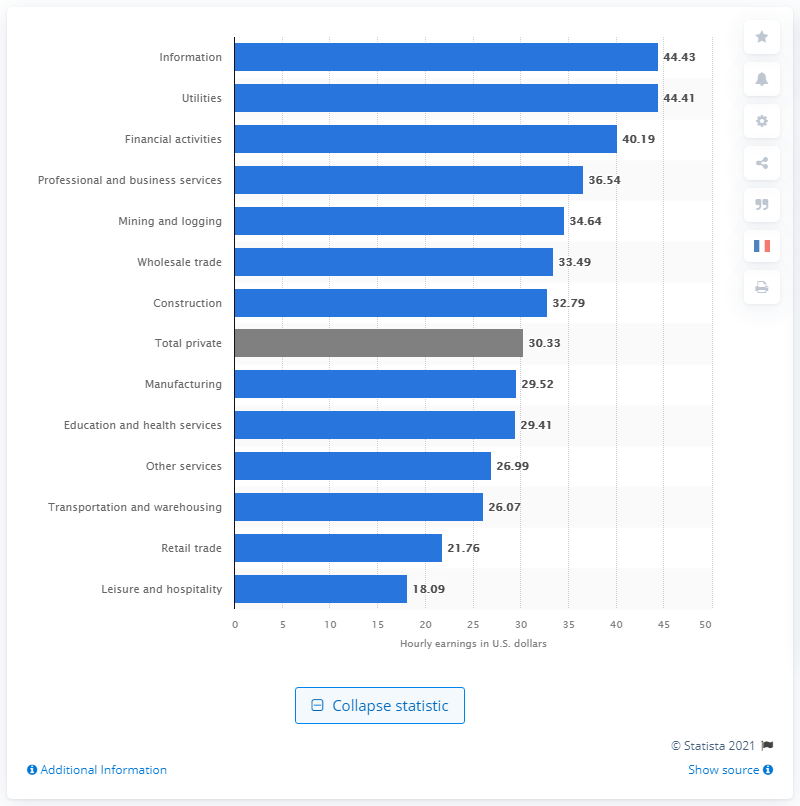Outline some significant characteristics in this image. In May 2021, the average hourly earnings for all employees on private nonfarm payrolls in the United States was 30.33 dollars. 